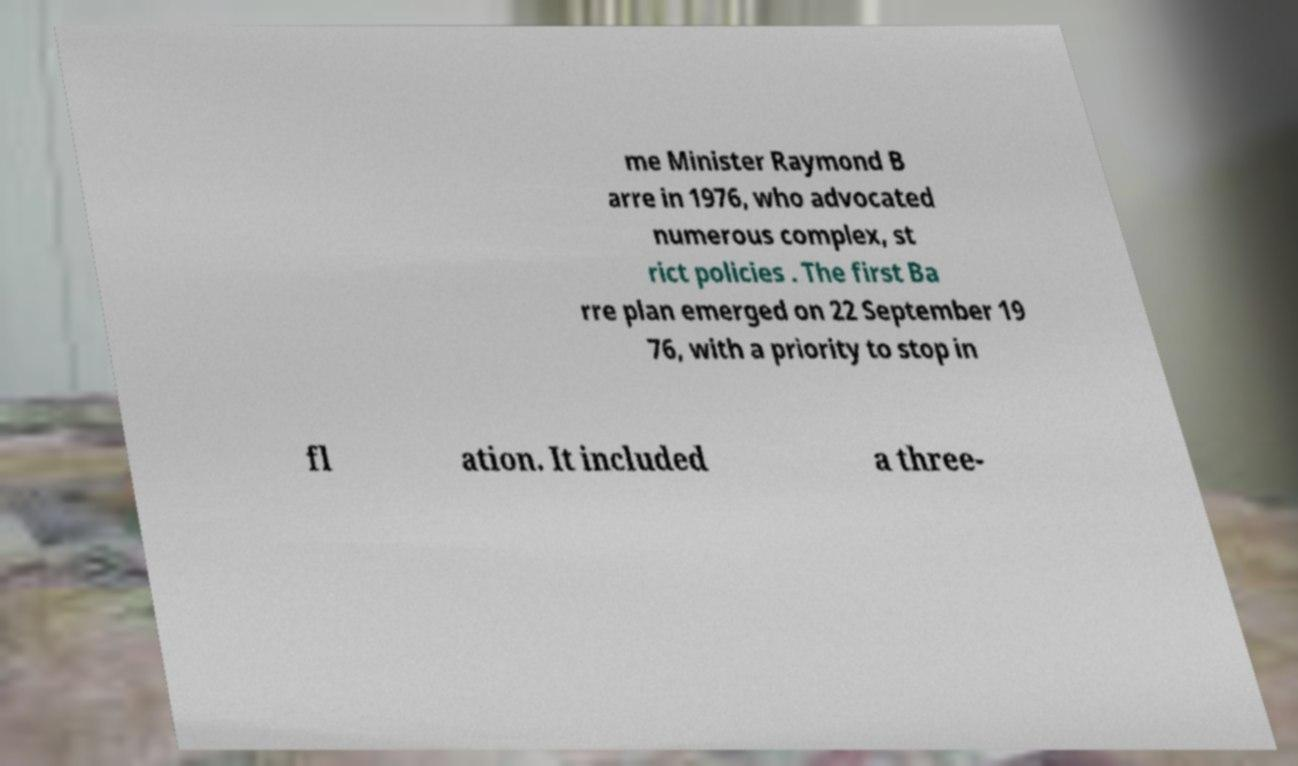Can you accurately transcribe the text from the provided image for me? me Minister Raymond B arre in 1976, who advocated numerous complex, st rict policies . The first Ba rre plan emerged on 22 September 19 76, with a priority to stop in fl ation. It included a three- 